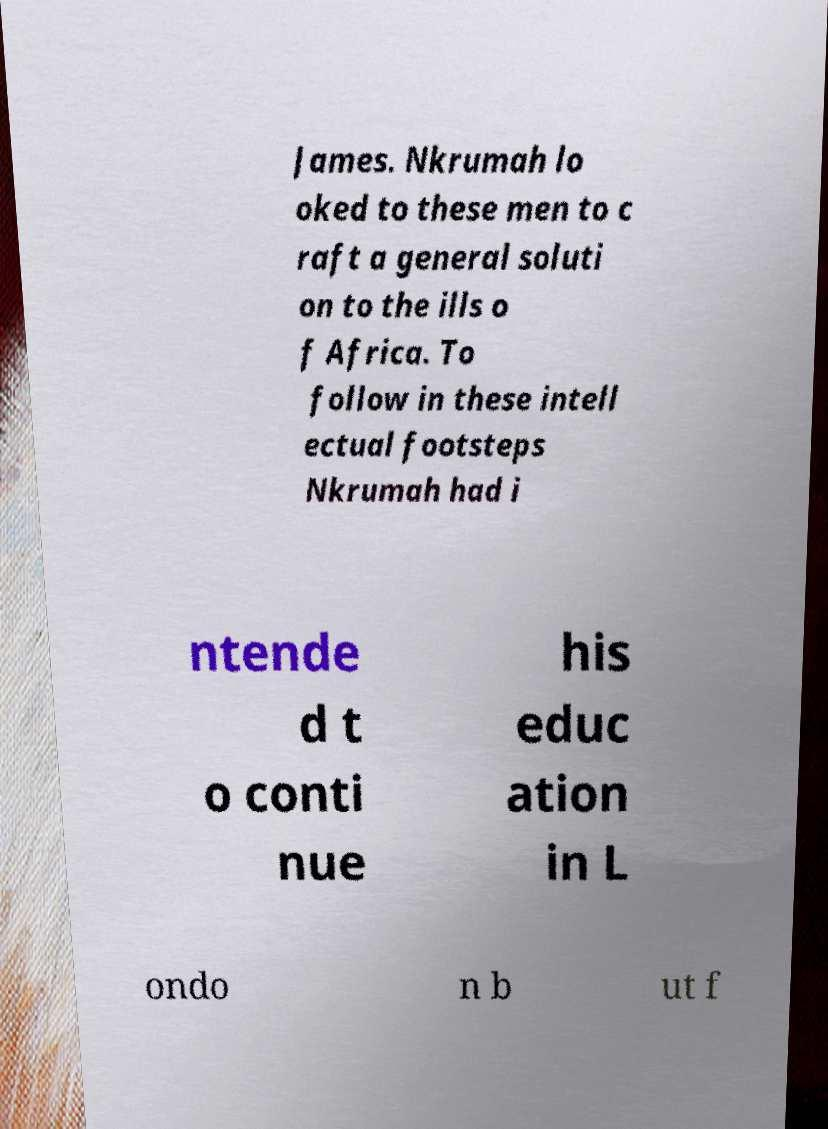I need the written content from this picture converted into text. Can you do that? James. Nkrumah lo oked to these men to c raft a general soluti on to the ills o f Africa. To follow in these intell ectual footsteps Nkrumah had i ntende d t o conti nue his educ ation in L ondo n b ut f 